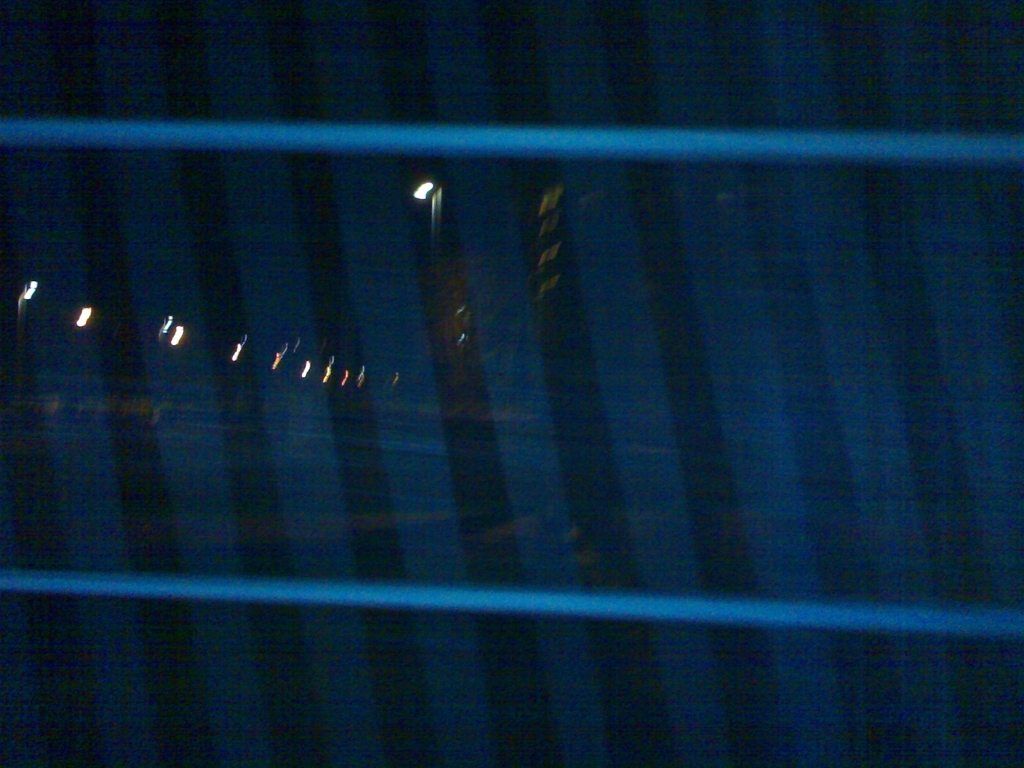Can you describe the mood or atmosphere this image evokes? The image evokes a mysterious and somber mood. The darkness and the blurred glimpse of lights through what appears to be a barrier of some sort add to a sense of isolation or perhaps curiosity about an obscured scene. It's reminiscent of looking out into the night from a confined space, which might stir feelings of introspection or contemplation. 